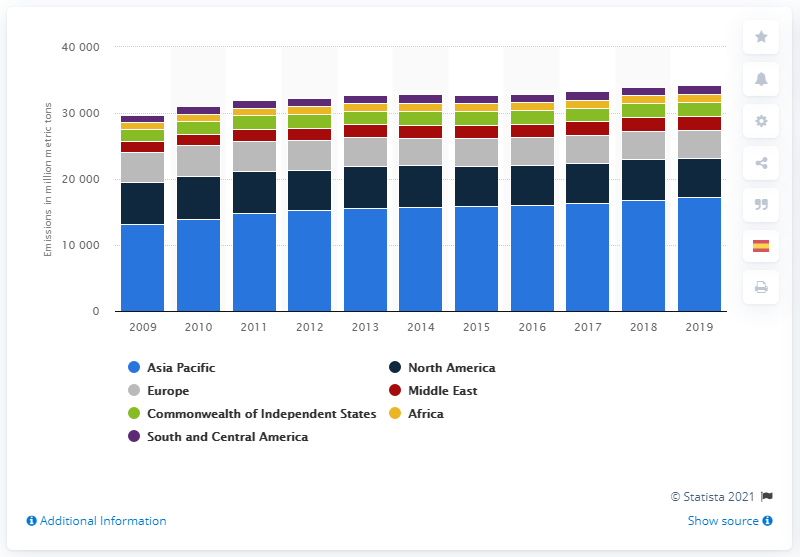Draw attention to some important aspects in this diagram. In 2019, a total of 17,269.5 million metric tons of carbon dioxide was emitted in the Asia Pacific region. The largest emitter of carbon dioxide in the world is in the Asia Pacific region. 